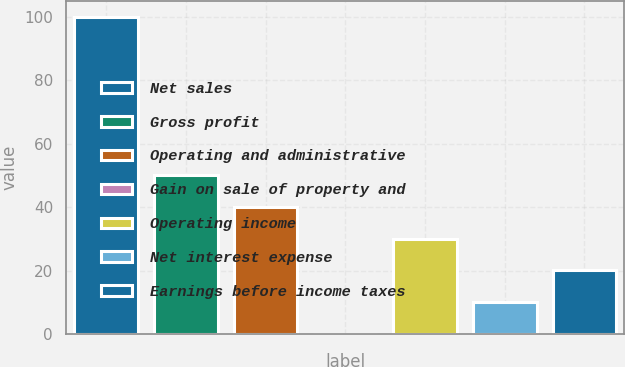Convert chart. <chart><loc_0><loc_0><loc_500><loc_500><bar_chart><fcel>Net sales<fcel>Gross profit<fcel>Operating and administrative<fcel>Gain on sale of property and<fcel>Operating income<fcel>Net interest expense<fcel>Earnings before income taxes<nl><fcel>100<fcel>50.06<fcel>40.07<fcel>0.11<fcel>30.08<fcel>10.1<fcel>20.09<nl></chart> 